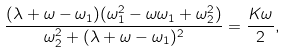<formula> <loc_0><loc_0><loc_500><loc_500>\frac { ( \lambda + \omega - \omega _ { 1 } ) ( \omega _ { 1 } ^ { 2 } - \omega \omega _ { 1 } + \omega _ { 2 } ^ { 2 } ) } { \omega _ { 2 } ^ { 2 } + ( \lambda + \omega - \omega _ { 1 } ) ^ { 2 } } = \frac { K \omega } { 2 } ,</formula> 